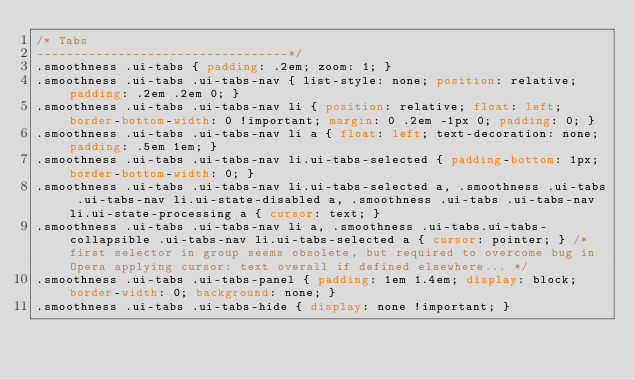<code> <loc_0><loc_0><loc_500><loc_500><_CSS_>/* Tabs
----------------------------------*/
.smoothness .ui-tabs { padding: .2em; zoom: 1; }
.smoothness .ui-tabs .ui-tabs-nav { list-style: none; position: relative; padding: .2em .2em 0; }
.smoothness .ui-tabs .ui-tabs-nav li { position: relative; float: left; border-bottom-width: 0 !important; margin: 0 .2em -1px 0; padding: 0; }
.smoothness .ui-tabs .ui-tabs-nav li a { float: left; text-decoration: none; padding: .5em 1em; }
.smoothness .ui-tabs .ui-tabs-nav li.ui-tabs-selected { padding-bottom: 1px; border-bottom-width: 0; }
.smoothness .ui-tabs .ui-tabs-nav li.ui-tabs-selected a, .smoothness .ui-tabs .ui-tabs-nav li.ui-state-disabled a, .smoothness .ui-tabs .ui-tabs-nav li.ui-state-processing a { cursor: text; }
.smoothness .ui-tabs .ui-tabs-nav li a, .smoothness .ui-tabs.ui-tabs-collapsible .ui-tabs-nav li.ui-tabs-selected a { cursor: pointer; } /* first selector in group seems obsolete, but required to overcome bug in Opera applying cursor: text overall if defined elsewhere... */
.smoothness .ui-tabs .ui-tabs-panel { padding: 1em 1.4em; display: block; border-width: 0; background: none; }
.smoothness .ui-tabs .ui-tabs-hide { display: none !important; }
</code> 